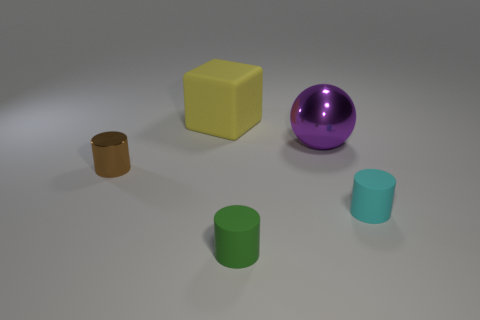There is a metallic thing left of the cube; how many small cyan things are left of it?
Offer a terse response. 0. Is the material of the cylinder to the right of the green matte thing the same as the cylinder left of the green cylinder?
Provide a succinct answer. No. How many blue things have the same shape as the tiny green thing?
Make the answer very short. 0. How many large balls are the same color as the large rubber thing?
Ensure brevity in your answer.  0. There is a small thing that is in front of the cyan cylinder; does it have the same shape as the metallic object behind the shiny cylinder?
Make the answer very short. No. How many things are in front of the object that is to the left of the large object that is left of the small green matte cylinder?
Provide a short and direct response. 2. There is a big object on the right side of the rubber thing that is behind the small object that is on the left side of the yellow matte object; what is its material?
Offer a very short reply. Metal. Does the big object in front of the large yellow rubber cube have the same material as the large cube?
Make the answer very short. No. How many purple objects are the same size as the yellow object?
Ensure brevity in your answer.  1. Is the number of big matte cubes on the right side of the big yellow matte thing greater than the number of tiny cyan rubber cylinders to the left of the brown object?
Provide a succinct answer. No. 